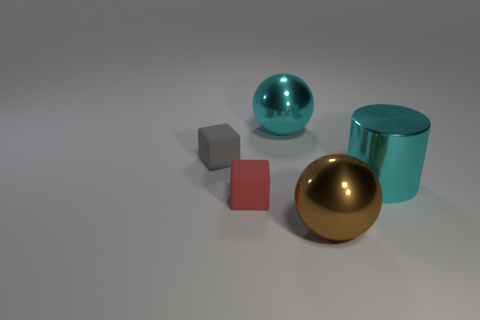Add 3 small gray objects. How many objects exist? 8 Subtract all balls. How many objects are left? 3 Add 5 tiny blocks. How many tiny blocks exist? 7 Subtract 0 red balls. How many objects are left? 5 Subtract all big cylinders. Subtract all cyan balls. How many objects are left? 3 Add 5 red objects. How many red objects are left? 6 